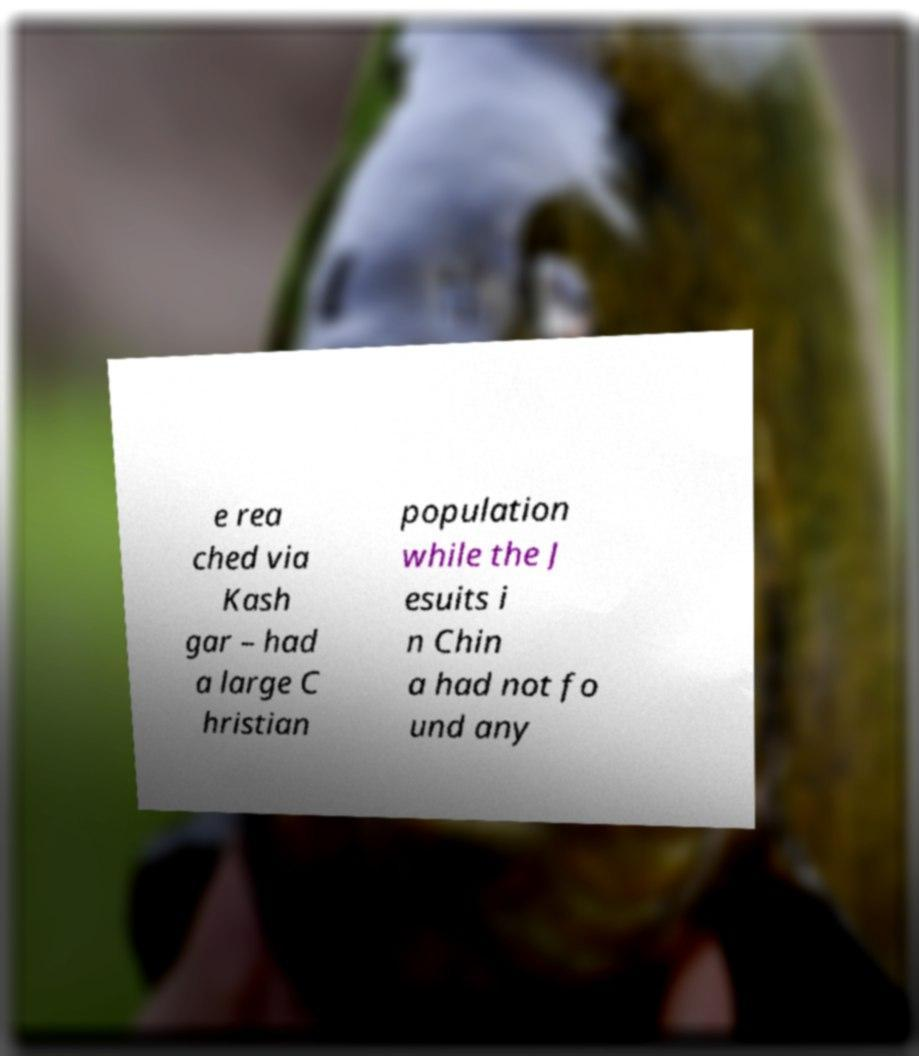There's text embedded in this image that I need extracted. Can you transcribe it verbatim? e rea ched via Kash gar – had a large C hristian population while the J esuits i n Chin a had not fo und any 